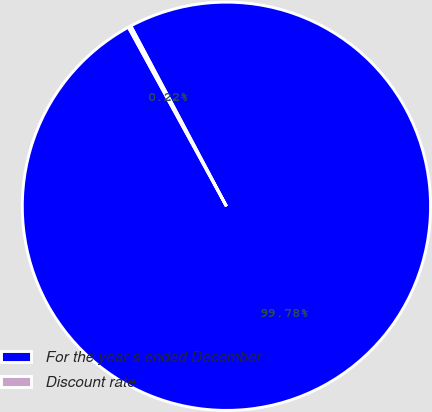Convert chart to OTSL. <chart><loc_0><loc_0><loc_500><loc_500><pie_chart><fcel>For the year s ended December<fcel>Discount rate<nl><fcel>99.78%<fcel>0.22%<nl></chart> 